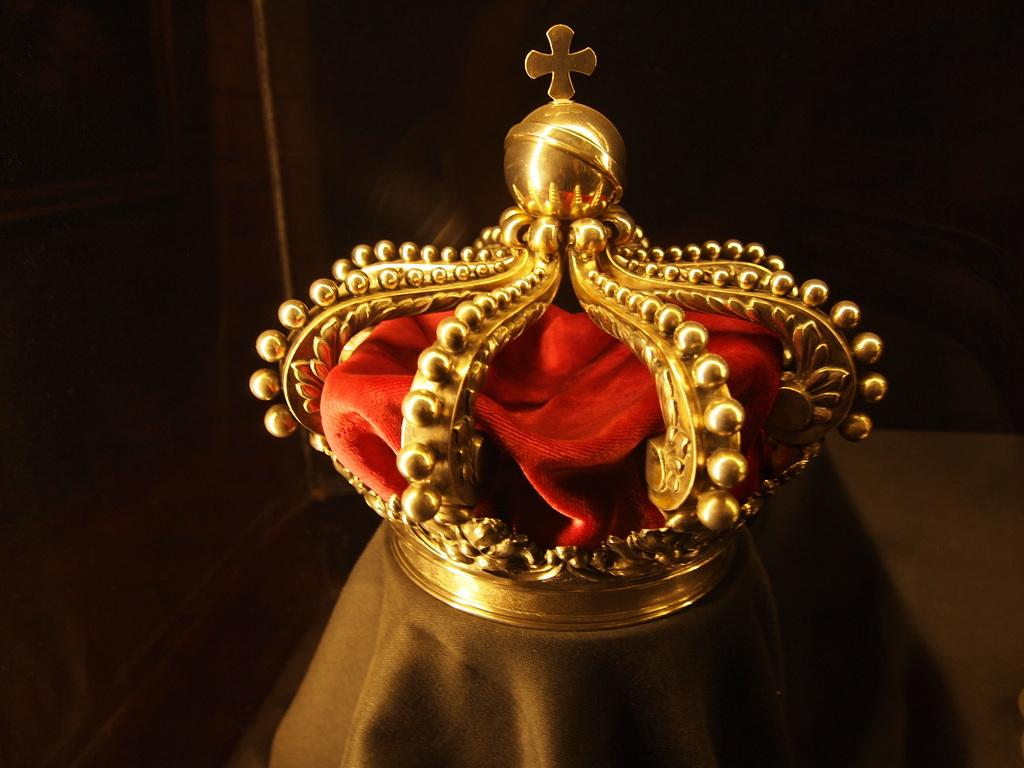What is the main object in the image? There is a golden crown in the image. What other item is present in the image? There is a red cloth in the image. Where are the crown and cloth located? Both the crown and cloth are on a platform. What can be observed about the background of the image? The background of the image is dark. What type of match is being played in the image? There is no match being played in the image; it features a golden crown and a red cloth on a platform with a dark background. What effect does the top have on the crown in the image? There is no top present in the image, and therefore no effect on the crown can be observed. 